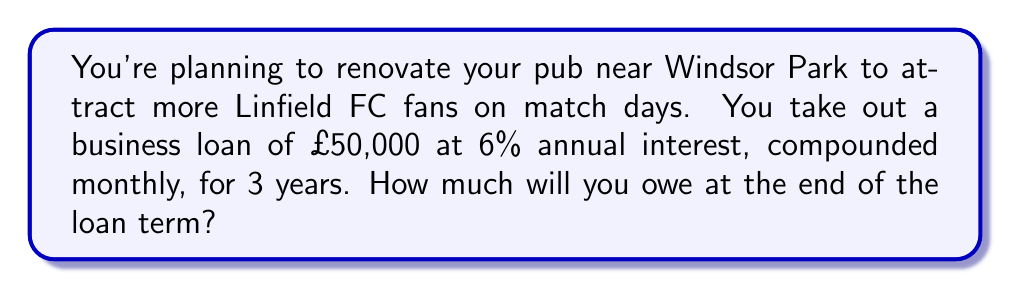Could you help me with this problem? Let's approach this step-by-step:

1) The formula for compound interest is:
   $$A = P(1 + \frac{r}{n})^{nt}$$
   Where:
   $A$ = final amount
   $P$ = principal (initial loan amount)
   $r$ = annual interest rate (in decimal form)
   $n$ = number of times interest is compounded per year
   $t$ = number of years

2) Given information:
   $P = £50,000$
   $r = 6\% = 0.06$
   $n = 12$ (compounded monthly)
   $t = 3$ years

3) Substituting these values into the formula:
   $$A = 50000(1 + \frac{0.06}{12})^{12 \cdot 3}$$

4) Simplify inside the parentheses:
   $$A = 50000(1 + 0.005)^{36}$$

5) Calculate the exponent:
   $$A = 50000(1.005)^{36}$$

6) Use a calculator to compute this:
   $$A = 50000 \cdot 1.1972$$
   $$A = 59,860.00$$

Therefore, you will owe £59,860.00 at the end of the 3-year term.
Answer: £59,860.00 